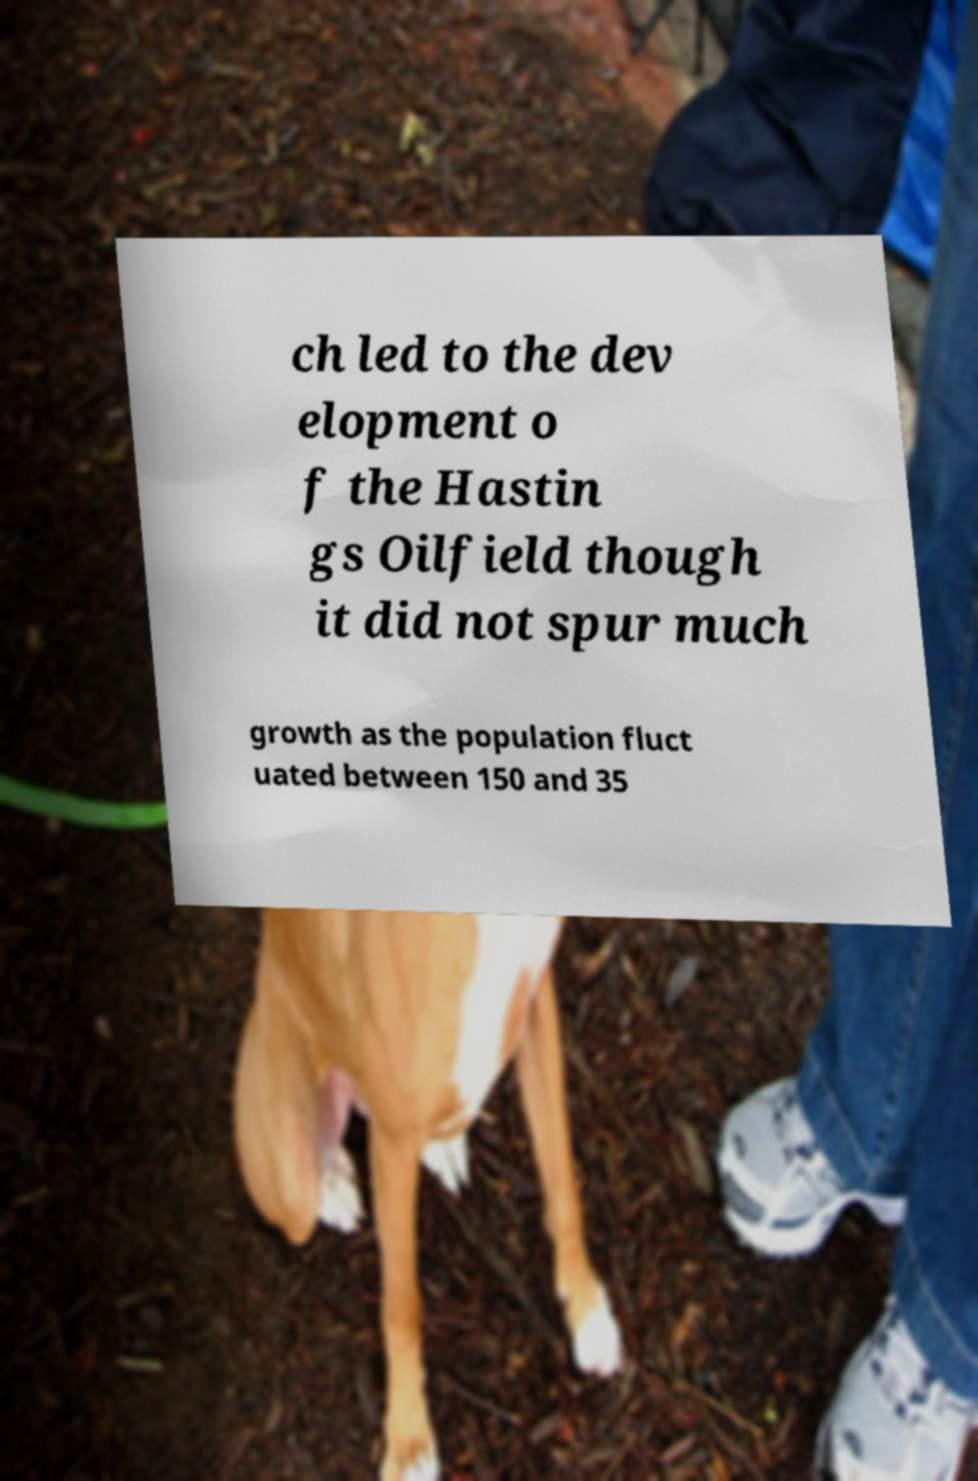There's text embedded in this image that I need extracted. Can you transcribe it verbatim? ch led to the dev elopment o f the Hastin gs Oilfield though it did not spur much growth as the population fluct uated between 150 and 35 